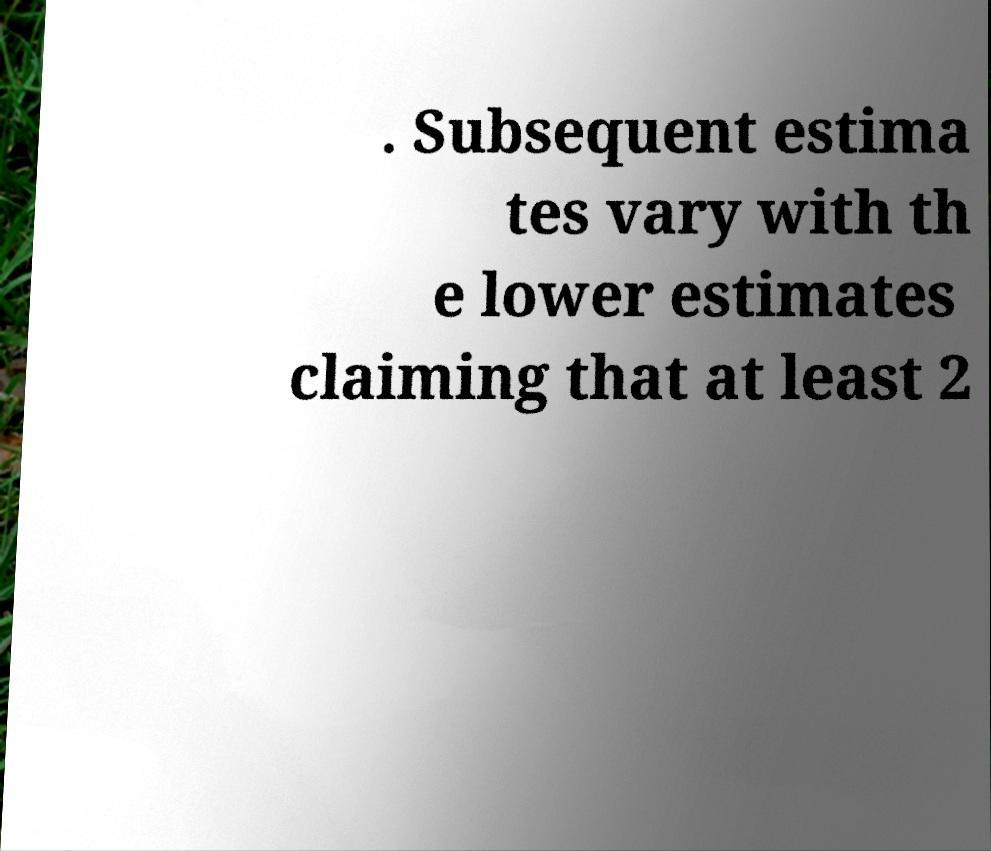Please identify and transcribe the text found in this image. . Subsequent estima tes vary with th e lower estimates claiming that at least 2 